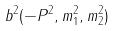Convert formula to latex. <formula><loc_0><loc_0><loc_500><loc_500>b ^ { 2 } ( - P ^ { 2 } , m _ { 1 } ^ { 2 } , m _ { 2 } ^ { 2 } )</formula> 